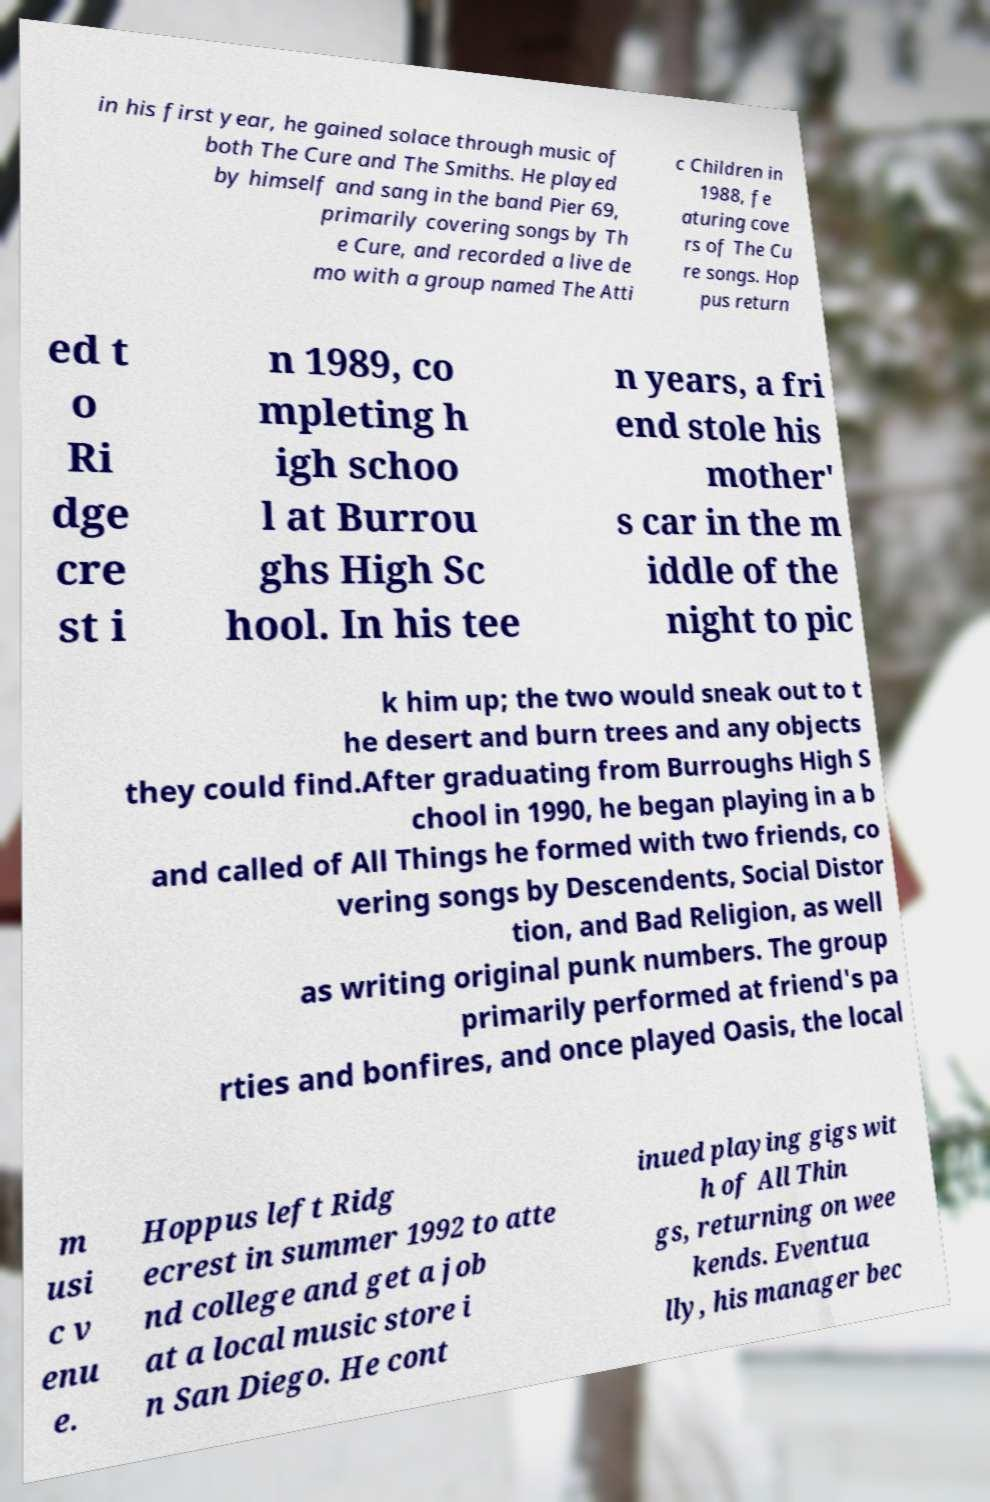Can you accurately transcribe the text from the provided image for me? in his first year, he gained solace through music of both The Cure and The Smiths. He played by himself and sang in the band Pier 69, primarily covering songs by Th e Cure, and recorded a live de mo with a group named The Atti c Children in 1988, fe aturing cove rs of The Cu re songs. Hop pus return ed t o Ri dge cre st i n 1989, co mpleting h igh schoo l at Burrou ghs High Sc hool. In his tee n years, a fri end stole his mother' s car in the m iddle of the night to pic k him up; the two would sneak out to t he desert and burn trees and any objects they could find.After graduating from Burroughs High S chool in 1990, he began playing in a b and called of All Things he formed with two friends, co vering songs by Descendents, Social Distor tion, and Bad Religion, as well as writing original punk numbers. The group primarily performed at friend's pa rties and bonfires, and once played Oasis, the local m usi c v enu e. Hoppus left Ridg ecrest in summer 1992 to atte nd college and get a job at a local music store i n San Diego. He cont inued playing gigs wit h of All Thin gs, returning on wee kends. Eventua lly, his manager bec 